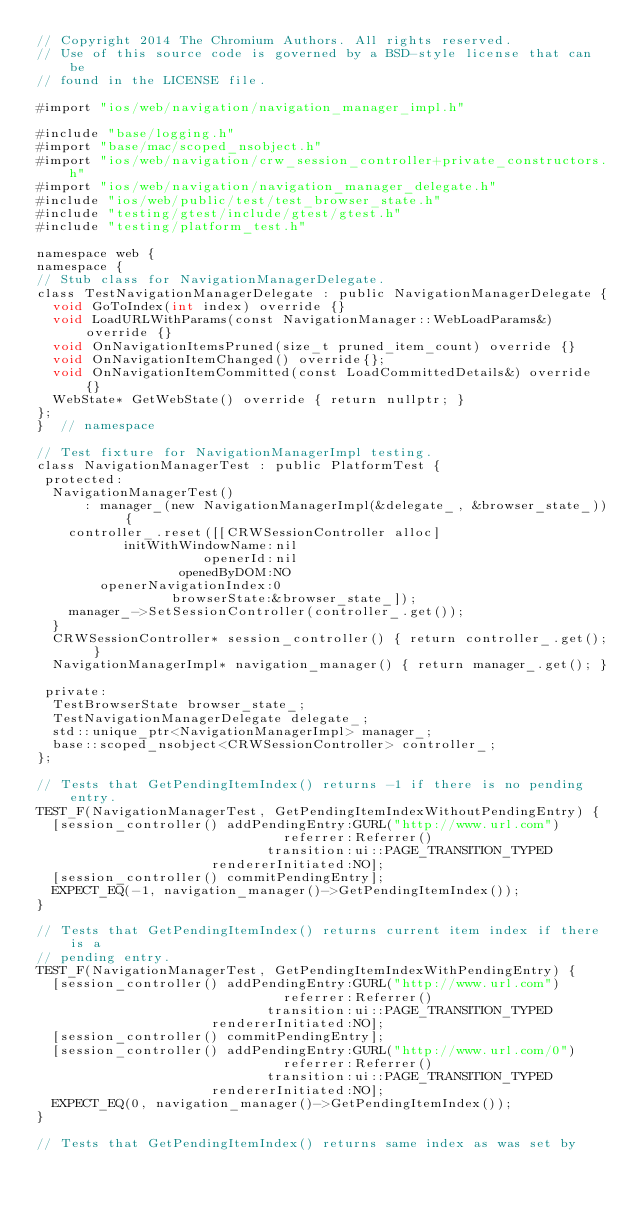Convert code to text. <code><loc_0><loc_0><loc_500><loc_500><_ObjectiveC_>// Copyright 2014 The Chromium Authors. All rights reserved.
// Use of this source code is governed by a BSD-style license that can be
// found in the LICENSE file.

#import "ios/web/navigation/navigation_manager_impl.h"

#include "base/logging.h"
#import "base/mac/scoped_nsobject.h"
#import "ios/web/navigation/crw_session_controller+private_constructors.h"
#import "ios/web/navigation/navigation_manager_delegate.h"
#include "ios/web/public/test/test_browser_state.h"
#include "testing/gtest/include/gtest/gtest.h"
#include "testing/platform_test.h"

namespace web {
namespace {
// Stub class for NavigationManagerDelegate.
class TestNavigationManagerDelegate : public NavigationManagerDelegate {
  void GoToIndex(int index) override {}
  void LoadURLWithParams(const NavigationManager::WebLoadParams&) override {}
  void OnNavigationItemsPruned(size_t pruned_item_count) override {}
  void OnNavigationItemChanged() override{};
  void OnNavigationItemCommitted(const LoadCommittedDetails&) override {}
  WebState* GetWebState() override { return nullptr; }
};
}  // namespace

// Test fixture for NavigationManagerImpl testing.
class NavigationManagerTest : public PlatformTest {
 protected:
  NavigationManagerTest()
      : manager_(new NavigationManagerImpl(&delegate_, &browser_state_)) {
    controller_.reset([[CRWSessionController alloc]
           initWithWindowName:nil
                     openerId:nil
                  openedByDOM:NO
        openerNavigationIndex:0
                 browserState:&browser_state_]);
    manager_->SetSessionController(controller_.get());
  }
  CRWSessionController* session_controller() { return controller_.get(); }
  NavigationManagerImpl* navigation_manager() { return manager_.get(); }

 private:
  TestBrowserState browser_state_;
  TestNavigationManagerDelegate delegate_;
  std::unique_ptr<NavigationManagerImpl> manager_;
  base::scoped_nsobject<CRWSessionController> controller_;
};

// Tests that GetPendingItemIndex() returns -1 if there is no pending entry.
TEST_F(NavigationManagerTest, GetPendingItemIndexWithoutPendingEntry) {
  [session_controller() addPendingEntry:GURL("http://www.url.com")
                               referrer:Referrer()
                             transition:ui::PAGE_TRANSITION_TYPED
                      rendererInitiated:NO];
  [session_controller() commitPendingEntry];
  EXPECT_EQ(-1, navigation_manager()->GetPendingItemIndex());
}

// Tests that GetPendingItemIndex() returns current item index if there is a
// pending entry.
TEST_F(NavigationManagerTest, GetPendingItemIndexWithPendingEntry) {
  [session_controller() addPendingEntry:GURL("http://www.url.com")
                               referrer:Referrer()
                             transition:ui::PAGE_TRANSITION_TYPED
                      rendererInitiated:NO];
  [session_controller() commitPendingEntry];
  [session_controller() addPendingEntry:GURL("http://www.url.com/0")
                               referrer:Referrer()
                             transition:ui::PAGE_TRANSITION_TYPED
                      rendererInitiated:NO];
  EXPECT_EQ(0, navigation_manager()->GetPendingItemIndex());
}

// Tests that GetPendingItemIndex() returns same index as was set by</code> 